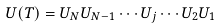Convert formula to latex. <formula><loc_0><loc_0><loc_500><loc_500>U ( T ) = U _ { N } U _ { N - 1 } \cdots U _ { j } \cdots U _ { 2 } U _ { 1 }</formula> 